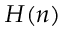Convert formula to latex. <formula><loc_0><loc_0><loc_500><loc_500>H ( n )</formula> 